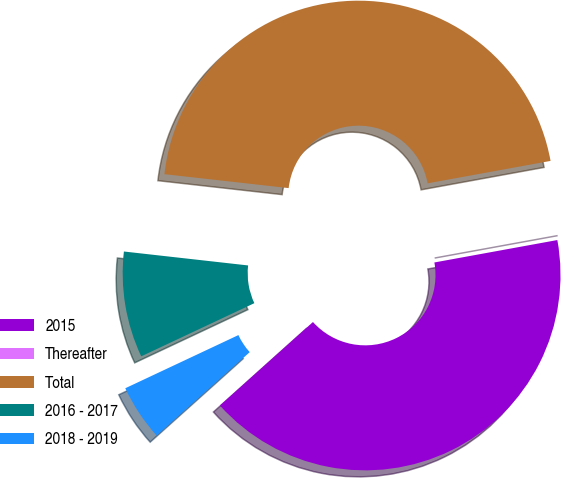Convert chart to OTSL. <chart><loc_0><loc_0><loc_500><loc_500><pie_chart><fcel>2015<fcel>Thereafter<fcel>Total<fcel>2016 - 2017<fcel>2018 - 2019<nl><fcel>41.23%<fcel>0.0%<fcel>45.35%<fcel>8.77%<fcel>4.65%<nl></chart> 